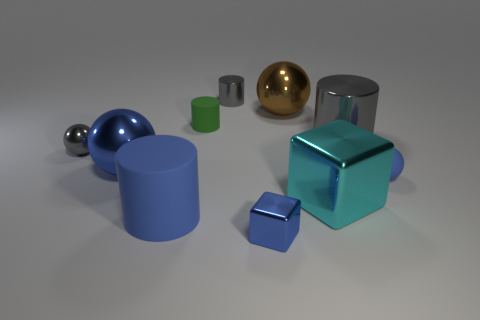Subtract all shiny balls. How many balls are left? 1 Subtract all gray balls. How many balls are left? 3 Subtract all cubes. How many objects are left? 8 Subtract 2 balls. How many balls are left? 2 Add 3 cyan matte cubes. How many cyan matte cubes exist? 3 Subtract 0 yellow spheres. How many objects are left? 10 Subtract all red cylinders. Subtract all purple spheres. How many cylinders are left? 4 Subtract all purple blocks. How many green cylinders are left? 1 Subtract all blue metallic things. Subtract all large brown metallic spheres. How many objects are left? 7 Add 9 green rubber cylinders. How many green rubber cylinders are left? 10 